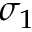Convert formula to latex. <formula><loc_0><loc_0><loc_500><loc_500>\sigma _ { 1 }</formula> 